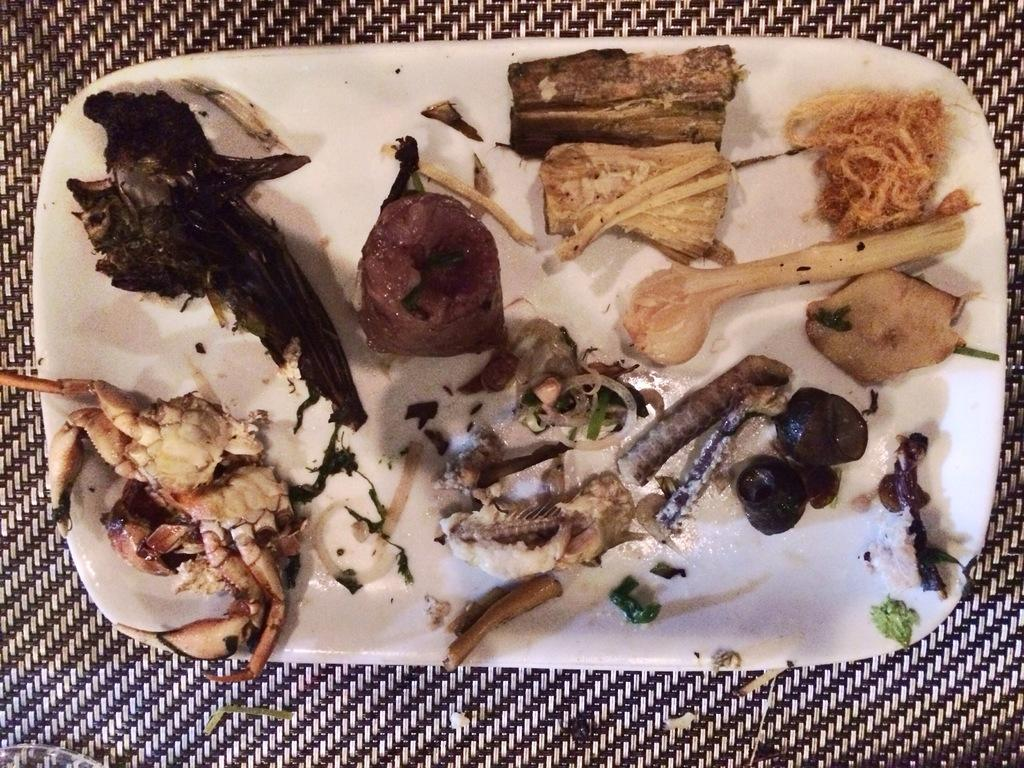What is on the plate in the image? There are food items on a plate in the image. What color is the plate? The plate is white. Where is the plate located in the image? The plate is placed on a surface. How many dogs are visible in the image? There are no dogs present in the image. What type of flame can be seen coming from the plate in the image? There is no flame present in the image; it is a plate with food items. 